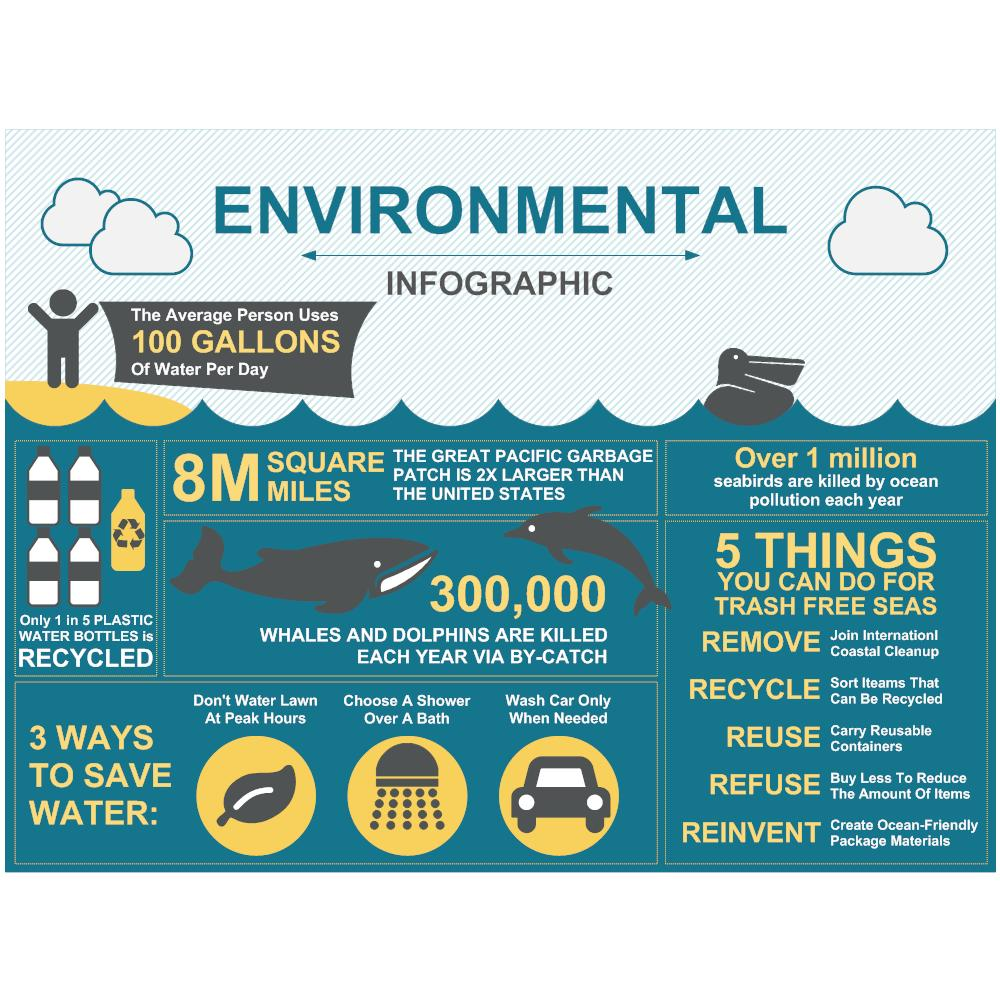List a handful of essential elements in this visual. Refuse and reinvent are the last two things on the list of different things to do for trash-free seas. The first three things on the list of different things to do for trash free seas are removing, recycling, and reusing. It is recommended to choose a shower over a bath in order to conserve water, as stated in the second point provided. According to recent estimates, only 20% of plastic water bottles are recycled. This is a significant issue as plastic waste continues to accumulate in our environment and pose a threat to wildlife. It is crucial that we increase our efforts to properly recycle and reduce the use of plastic water bottles in order to protect our planet. Refuse" is the second-to-last item on the list of actions that can help make seas trash-free. 